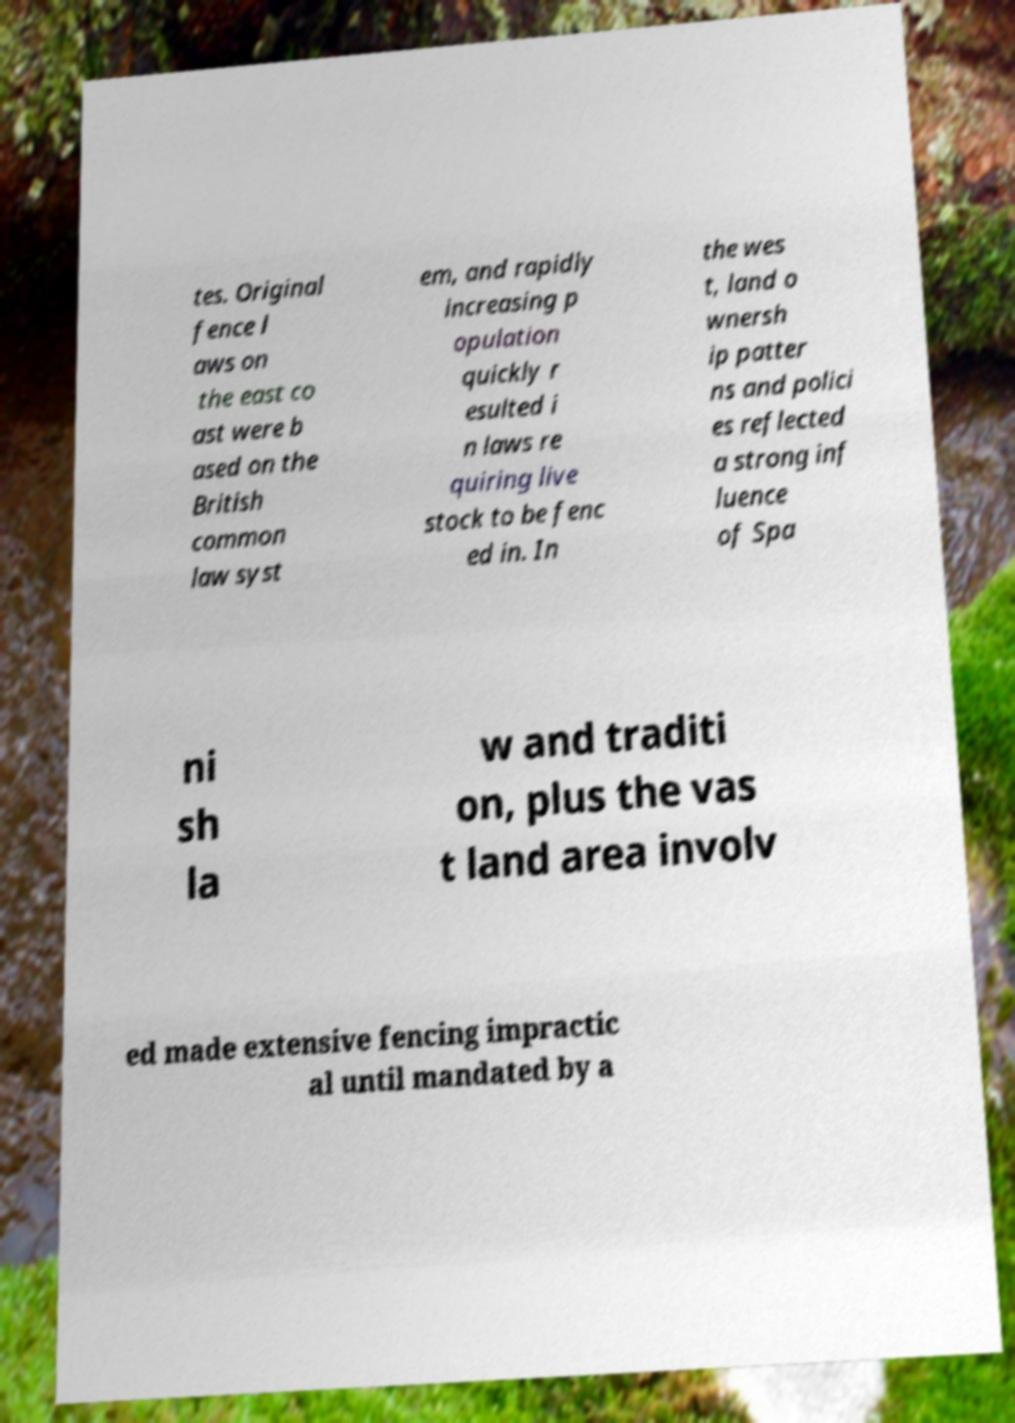Can you accurately transcribe the text from the provided image for me? tes. Original fence l aws on the east co ast were b ased on the British common law syst em, and rapidly increasing p opulation quickly r esulted i n laws re quiring live stock to be fenc ed in. In the wes t, land o wnersh ip patter ns and polici es reflected a strong inf luence of Spa ni sh la w and traditi on, plus the vas t land area involv ed made extensive fencing impractic al until mandated by a 